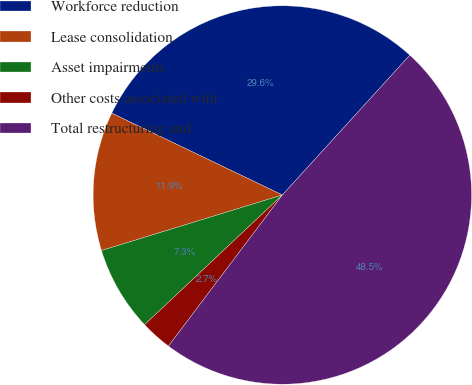Convert chart. <chart><loc_0><loc_0><loc_500><loc_500><pie_chart><fcel>Workforce reduction<fcel>Lease consolidation<fcel>Asset impairments<fcel>Other costs associated with<fcel>Total restructuring and<nl><fcel>29.65%<fcel>11.86%<fcel>7.28%<fcel>2.7%<fcel>48.52%<nl></chart> 